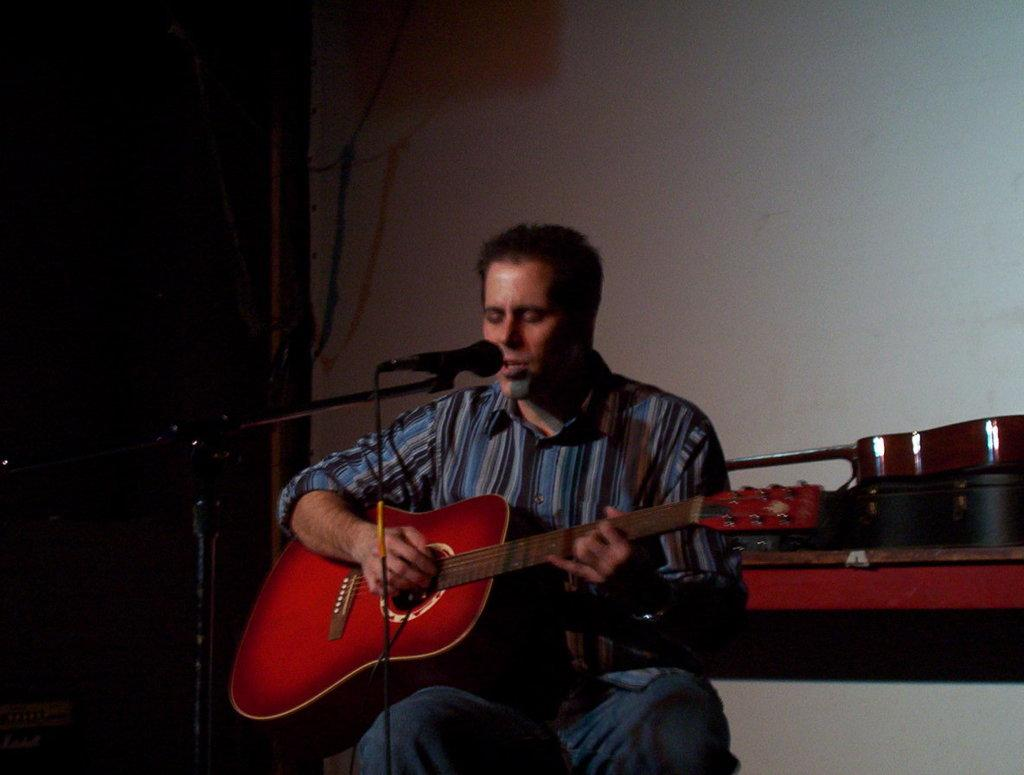What is the man in the image doing? The man is sitting, playing the guitar, and singing. What object is the man holding in his hand? The man is holding a guitar in his hand. What is the man using to amplify his voice? There is a microphone in the image, which the man might be using to amplify his voice. What can be seen in the background of the image? There is another guitar, a box, and a wall in the background. What type of scissors is the man using to make a discovery in the image? There are no scissors or any indication of a discovery in the image. The man is playing the guitar and singing. 